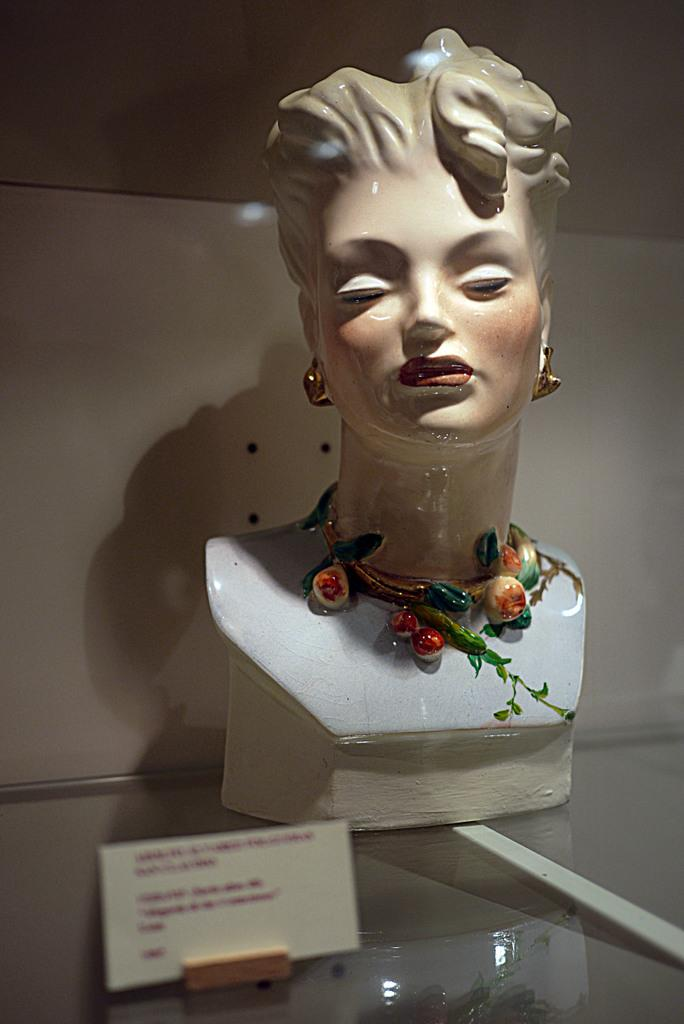What is the main feature in the center of the image? There is a decorative element in the center of the image. What is placed on the glass surface? A board is present on a glass surface. What can be seen in the background of the image? There is a wall visible in the background of the image. What type of heat can be felt coming from the decorative element in the image? There is no indication of heat or temperature in the image, and the decorative element does not appear to be a source of heat. 